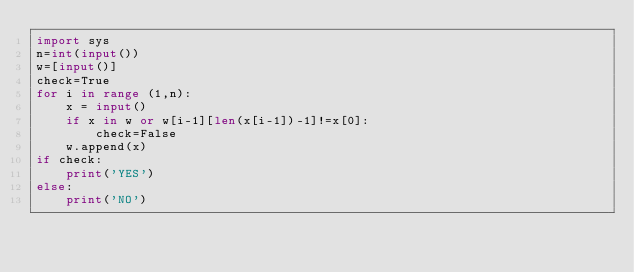<code> <loc_0><loc_0><loc_500><loc_500><_Python_>import sys
n=int(input())
w=[input()]
check=True
for i in range (1,n):
    x = input()
    if x in w or w[i-1][len(x[i-1])-1]!=x[0]:
        check=False
    w.append(x)
if check:
    print('YES')
else:
    print('NO')

</code> 